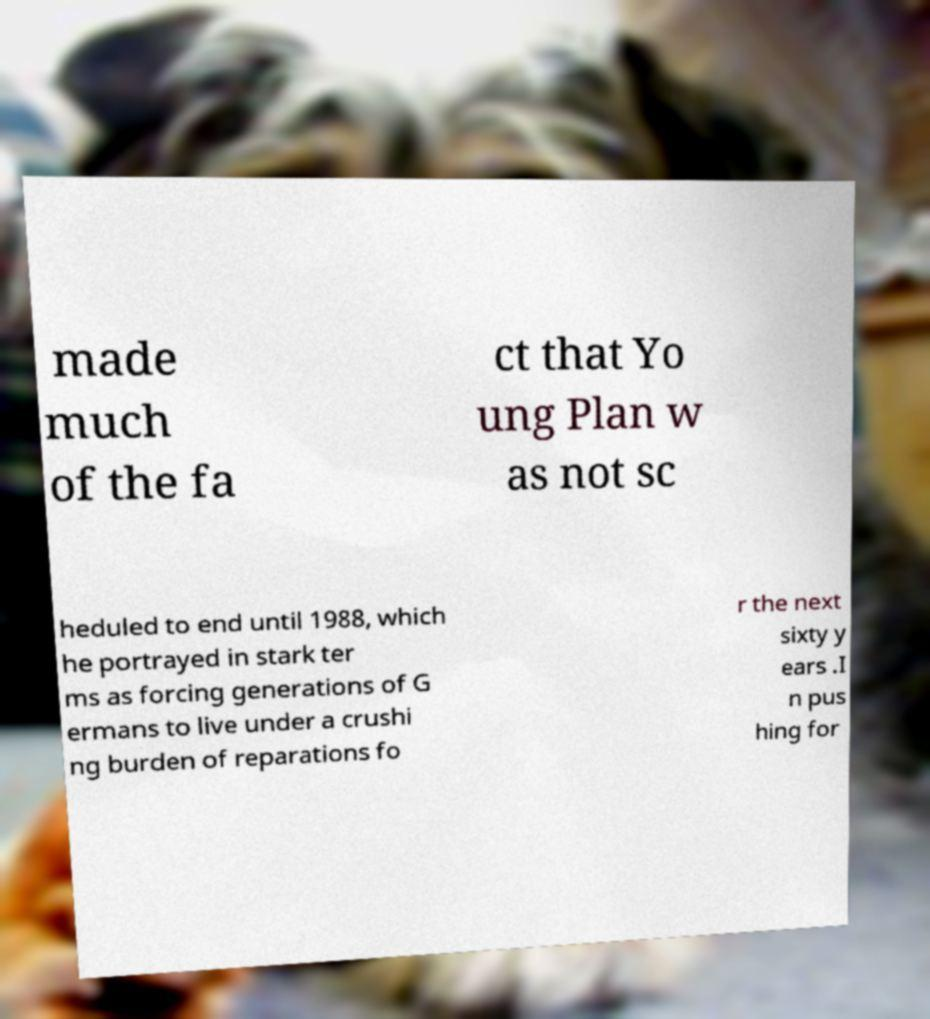Can you accurately transcribe the text from the provided image for me? made much of the fa ct that Yo ung Plan w as not sc heduled to end until 1988, which he portrayed in stark ter ms as forcing generations of G ermans to live under a crushi ng burden of reparations fo r the next sixty y ears .I n pus hing for 